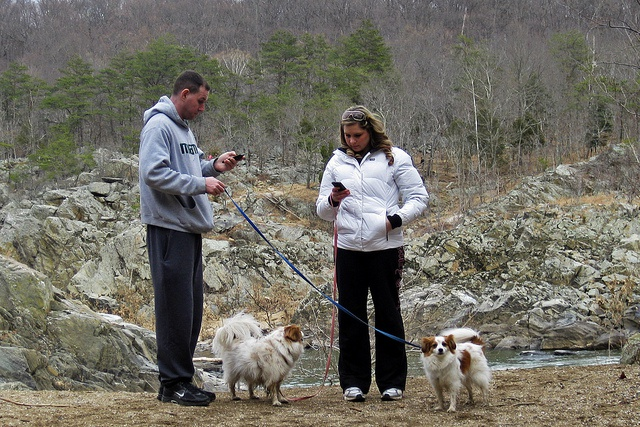Describe the objects in this image and their specific colors. I can see people in gray, black, lightgray, and darkgray tones, people in gray, black, and darkgray tones, dog in gray, darkgray, and lightgray tones, dog in gray, darkgray, lightgray, and black tones, and cell phone in gray and black tones in this image. 